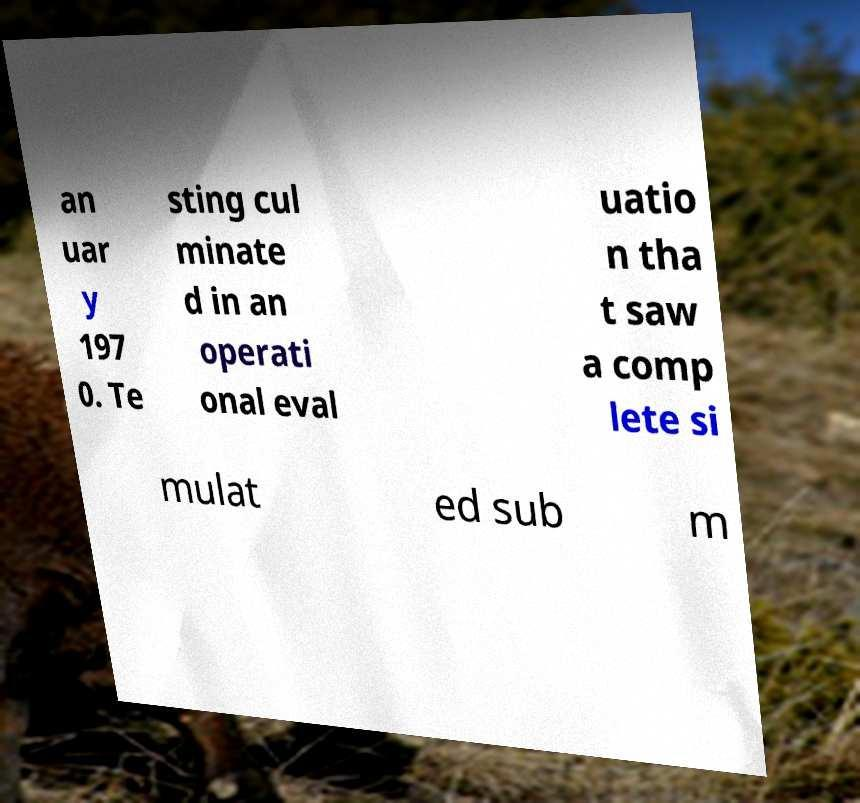Can you accurately transcribe the text from the provided image for me? an uar y 197 0. Te sting cul minate d in an operati onal eval uatio n tha t saw a comp lete si mulat ed sub m 